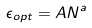<formula> <loc_0><loc_0><loc_500><loc_500>\epsilon _ { o p t } = A N ^ { a }</formula> 